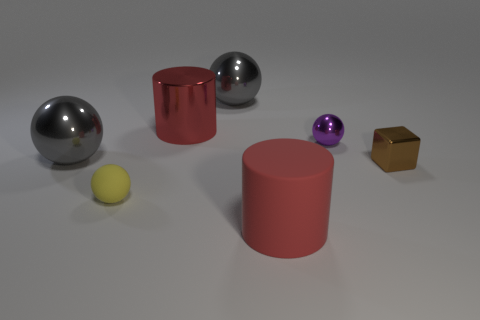Add 2 matte spheres. How many objects exist? 9 Subtract all cubes. How many objects are left? 6 Subtract all green matte cylinders. Subtract all yellow objects. How many objects are left? 6 Add 6 big objects. How many big objects are left? 10 Add 7 rubber cylinders. How many rubber cylinders exist? 8 Subtract 0 cyan cylinders. How many objects are left? 7 